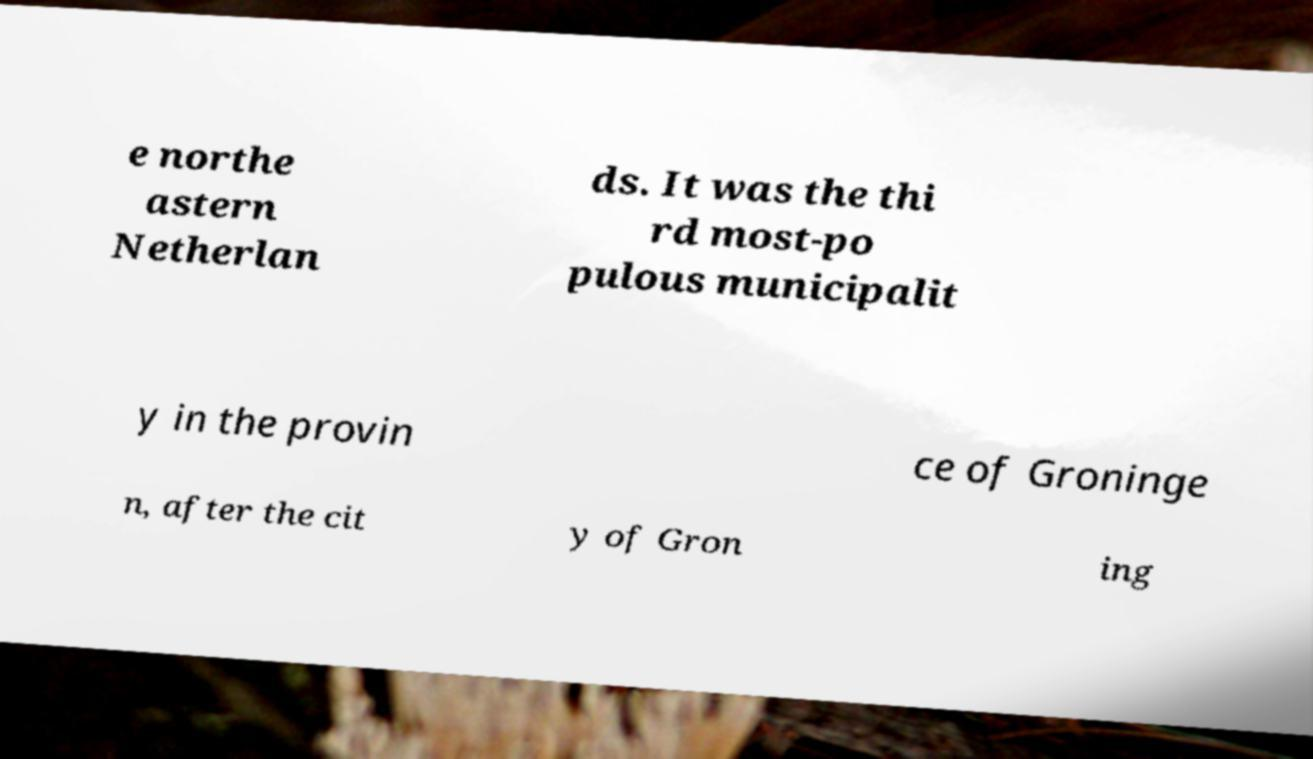I need the written content from this picture converted into text. Can you do that? e northe astern Netherlan ds. It was the thi rd most-po pulous municipalit y in the provin ce of Groninge n, after the cit y of Gron ing 